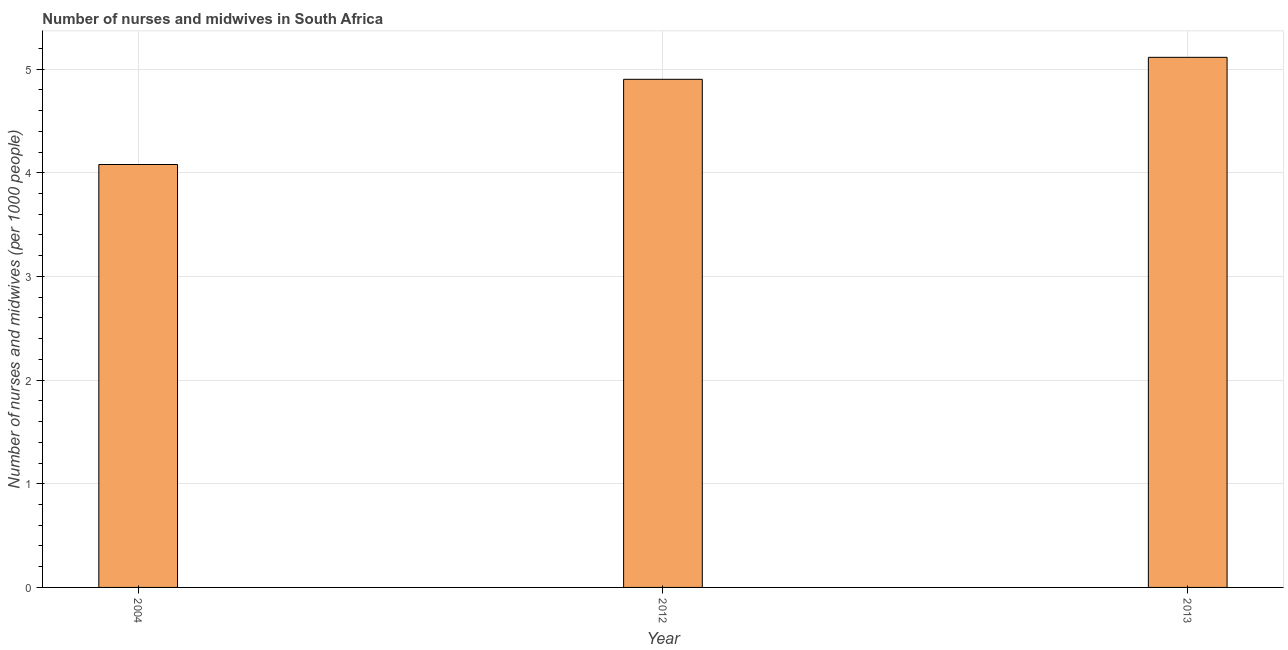Does the graph contain any zero values?
Offer a terse response. No. What is the title of the graph?
Keep it short and to the point. Number of nurses and midwives in South Africa. What is the label or title of the Y-axis?
Provide a short and direct response. Number of nurses and midwives (per 1000 people). What is the number of nurses and midwives in 2004?
Provide a short and direct response. 4.08. Across all years, what is the maximum number of nurses and midwives?
Offer a terse response. 5.11. Across all years, what is the minimum number of nurses and midwives?
Your answer should be very brief. 4.08. In which year was the number of nurses and midwives maximum?
Your response must be concise. 2013. In which year was the number of nurses and midwives minimum?
Provide a succinct answer. 2004. What is the sum of the number of nurses and midwives?
Ensure brevity in your answer.  14.1. What is the difference between the number of nurses and midwives in 2012 and 2013?
Offer a terse response. -0.21. What is the average number of nurses and midwives per year?
Ensure brevity in your answer.  4.7. What is the median number of nurses and midwives?
Provide a short and direct response. 4.9. What is the ratio of the number of nurses and midwives in 2012 to that in 2013?
Provide a succinct answer. 0.96. Is the number of nurses and midwives in 2004 less than that in 2013?
Offer a terse response. Yes. What is the difference between the highest and the second highest number of nurses and midwives?
Your answer should be compact. 0.21. Is the sum of the number of nurses and midwives in 2012 and 2013 greater than the maximum number of nurses and midwives across all years?
Keep it short and to the point. Yes. How many bars are there?
Ensure brevity in your answer.  3. What is the difference between two consecutive major ticks on the Y-axis?
Offer a very short reply. 1. What is the Number of nurses and midwives (per 1000 people) of 2004?
Provide a succinct answer. 4.08. What is the Number of nurses and midwives (per 1000 people) of 2012?
Keep it short and to the point. 4.9. What is the Number of nurses and midwives (per 1000 people) in 2013?
Provide a succinct answer. 5.11. What is the difference between the Number of nurses and midwives (per 1000 people) in 2004 and 2012?
Make the answer very short. -0.82. What is the difference between the Number of nurses and midwives (per 1000 people) in 2004 and 2013?
Offer a very short reply. -1.03. What is the difference between the Number of nurses and midwives (per 1000 people) in 2012 and 2013?
Keep it short and to the point. -0.21. What is the ratio of the Number of nurses and midwives (per 1000 people) in 2004 to that in 2012?
Keep it short and to the point. 0.83. What is the ratio of the Number of nurses and midwives (per 1000 people) in 2004 to that in 2013?
Offer a terse response. 0.8. 